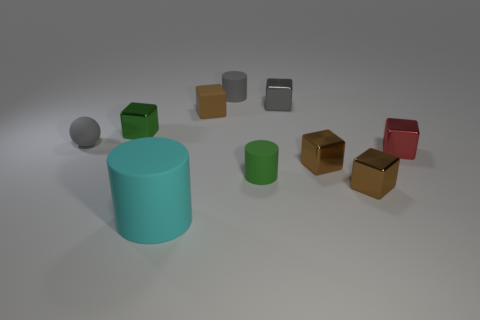Subtract all red balls. How many brown blocks are left? 3 Subtract 1 cubes. How many cubes are left? 5 Subtract all red blocks. How many blocks are left? 5 Subtract all tiny gray cubes. How many cubes are left? 5 Subtract all yellow cubes. Subtract all red balls. How many cubes are left? 6 Subtract all cylinders. How many objects are left? 7 Subtract all small brown matte blocks. Subtract all brown cubes. How many objects are left? 6 Add 3 tiny metal things. How many tiny metal things are left? 8 Add 8 small green matte cylinders. How many small green matte cylinders exist? 9 Subtract 1 red blocks. How many objects are left? 9 